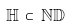Convert formula to latex. <formula><loc_0><loc_0><loc_500><loc_500>\mathbb { H } \, \subset \, \mathbb { N D }</formula> 